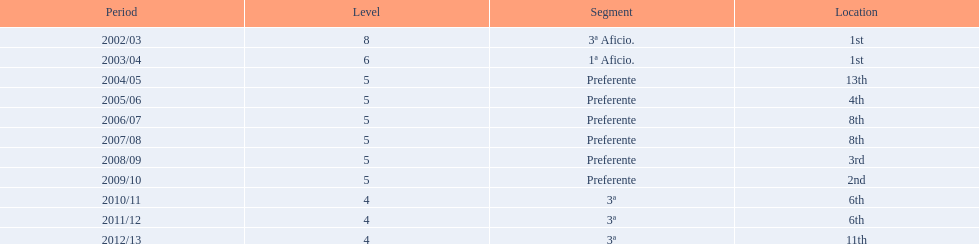What place was 1a aficio and 3a aficio? 1st. 